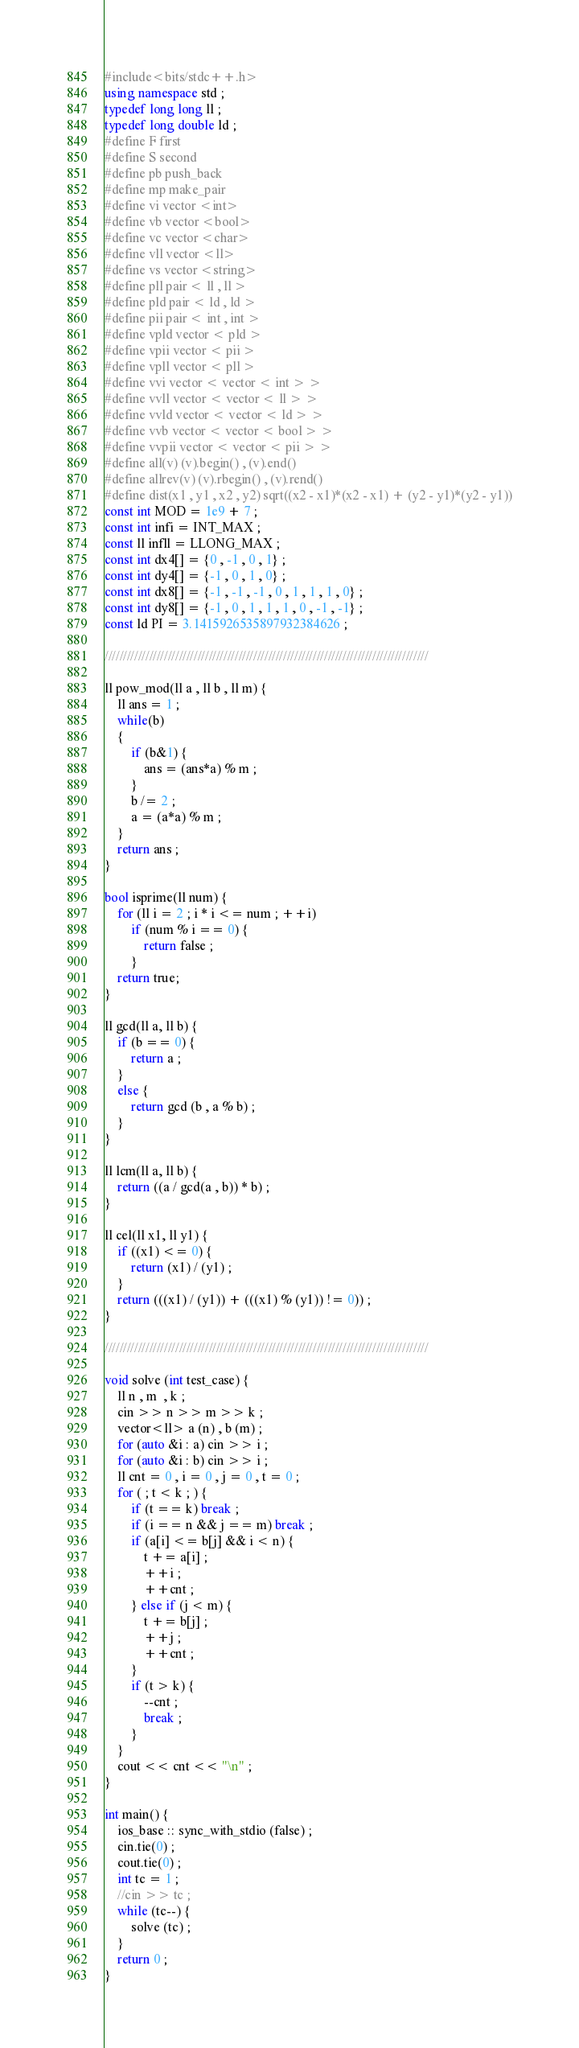Convert code to text. <code><loc_0><loc_0><loc_500><loc_500><_C++_>#include<bits/stdc++.h>
using namespace std ;
typedef long long ll ;
typedef long double ld ;
#define F first
#define S second
#define pb push_back 
#define mp make_pair
#define vi vector <int>
#define vb vector <bool>
#define vc vector <char>
#define vll vector <ll>
#define vs vector <string>
#define pll pair < ll , ll >
#define pld pair < ld , ld >
#define pii pair < int , int >
#define vpld vector < pld >
#define vpii vector < pii >
#define vpll vector < pll >
#define vvi vector < vector < int > >
#define vvll vector < vector < ll > >
#define vvld vector < vector < ld > >
#define vvb vector < vector < bool > >
#define vvpii vector < vector < pii > >
#define all(v) (v).begin() , (v).end()
#define allrev(v) (v).rbegin() , (v).rend()
#define dist(x1 , y1 , x2 , y2) sqrt((x2 - x1)*(x2 - x1) + (y2 - y1)*(y2 - y1))
const int MOD = 1e9 + 7 ;
const int infi = INT_MAX ;
const ll infll = LLONG_MAX ;
const int dx4[] = {0 , -1 , 0 , 1} ;
const int dy4[] = {-1 , 0 , 1 , 0} ;
const int dx8[] = {-1 , -1 , -1 , 0 , 1 , 1 , 1 , 0} ;
const int dy8[] = {-1 , 0 , 1 , 1 , 1 , 0 , -1 , -1} ;
const ld PI = 3.1415926535897932384626 ;

///////////////////////////////////////////////////////////////////////////////////////

ll pow_mod(ll a , ll b , ll m) {
	ll ans = 1 ;
	while(b)
	{
		if (b&1) {
			ans = (ans*a) % m ;
		}
		b /= 2 ;
		a = (a*a) % m ;
	}
	return ans ;
}

bool isprime(ll num) {
    for (ll i = 2 ; i * i <= num ; ++i)
        if (num % i == 0) {
        	return false ;
		}
    return true;
}

ll gcd(ll a, ll b) {
    if (b == 0) {
    	return a ;
	}
    else {
    	return gcd (b , a % b) ;
	}
}

ll lcm(ll a, ll b) {
    return ((a / gcd(a , b)) * b) ;
}

ll cel(ll x1, ll y1) {
    if ((x1) <= 0) {
        return (x1) / (y1) ;
    }
    return (((x1) / (y1)) + (((x1) % (y1)) != 0)) ;
}

///////////////////////////////////////////////////////////////////////////////////////

void solve (int test_case) {
	ll n , m  , k ;
	cin >> n >> m >> k ;
	vector<ll> a (n) , b (m) ;
	for (auto &i : a) cin >> i ;
	for (auto &i : b) cin >> i ;
	ll cnt = 0 , i = 0 , j = 0 , t = 0 ;
	for ( ; t < k ; ) {
		if (t == k) break ;
		if (i == n && j == m) break ;
		if (a[i] <= b[j] && i < n) {
			t += a[i] ;
			++i ;
			++cnt ;
		} else if (j < m) {
			t += b[j] ;
			++j ;
			++cnt ;
		}
		if (t > k) {
			--cnt ;
			break ;
		}
	}
	cout << cnt << "\n" ;
}

int main() {
	ios_base :: sync_with_stdio (false) ;
	cin.tie(0) ;
	cout.tie(0) ;
	int tc = 1 ;
	//cin >> tc ;
	while (tc--) {
		solve (tc) ;
	}
	return 0 ;
}</code> 